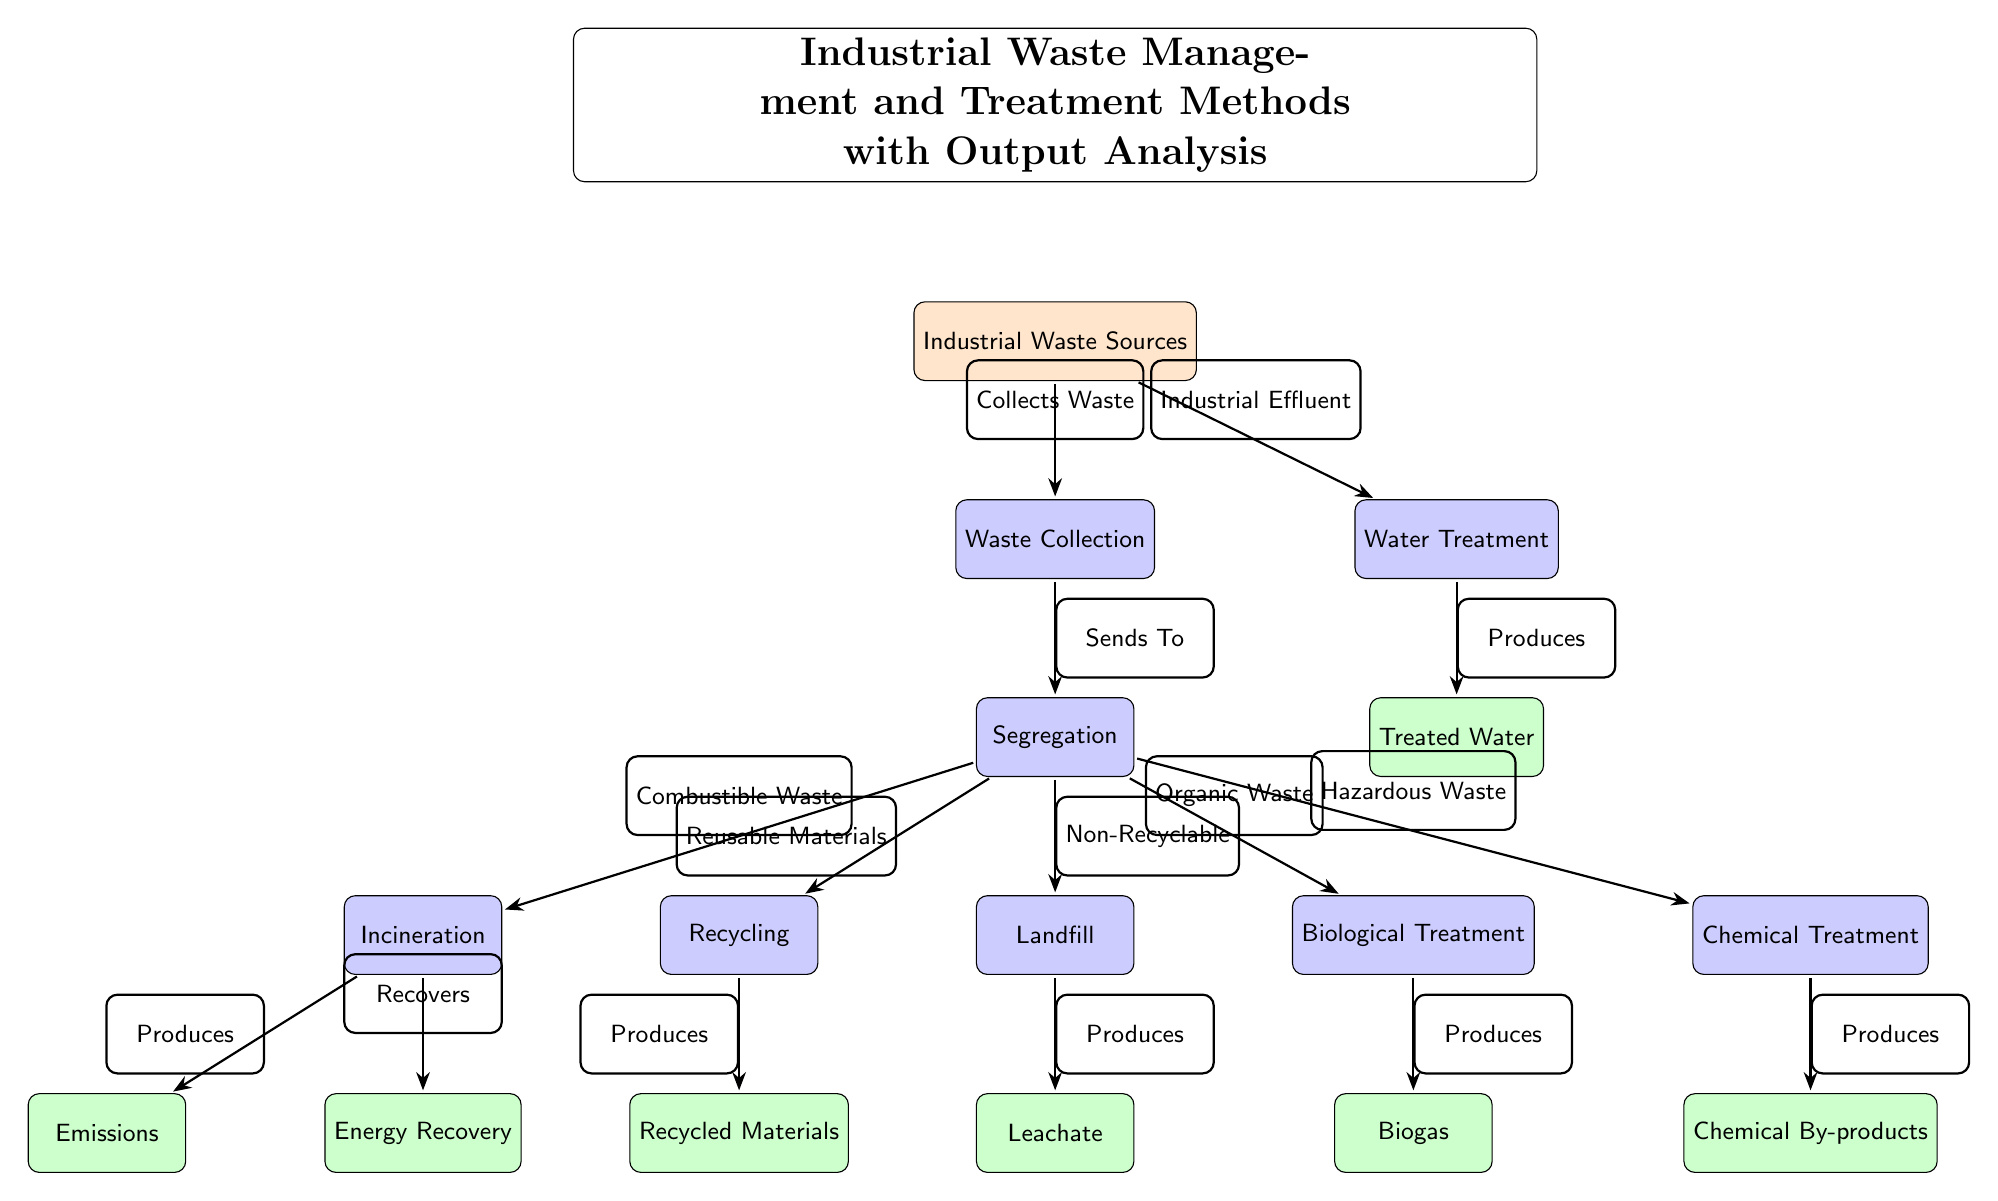What are the two main processes after waste collection? After waste collection, the diagram shows that the two main processes are segregation and water treatment. Segregation directly follows waste collection, while water treatment is another process that includes industrial effluent as input from the industrial waste sources.
Answer: Segregation and Water Treatment How many treatment methods are shown in the diagram? The diagram lists six treatment methods: recycling, incineration, landfill, biological treatment, chemical treatment, and water treatment. These methods detail how the segregated waste can be processed after the initial waste collection.
Answer: Six What type of output does incineration produce according to the diagram? According to the diagram, incineration produces emissions and energy recovery as outputs. The relationship indicates that combustible waste collected during segregation is handled by incineration to yield these outputs.
Answer: Emissions and Energy Recovery Which treatment method is associated with organic waste? The diagram specifies that biological treatment is associated with organic waste. The pathway from segregation to biological treatment illustrates that organic waste is specifically processed through this method.
Answer: Biological Treatment What is produced from chemical treatment? Chemical treatment produces chemical by-products as indicated in the diagram, showing the outcome of handling hazardous waste through this treatment method, following the segregation stage.
Answer: Chemical By-products Which output is connected to water treatment? The output directly connected to water treatment, according to the diagram, is treated water. This follows the water treatment process after the input of industrial effluent from industrial waste sources.
Answer: Treated Water Which treatment method has two distinct outputs? Incineration is the treatment method that has two distinct outputs, namely emissions and energy recovery. The dual output emphasizes the various results that can come from the incineration process in managing waste.
Answer: Incineration From where does industrial effluent directly feed into the diagram? Industrial effluent directly feeds into the water treatment process in the diagram. This highlights its flow as a significant component of waste management that requires specific treatment distinct from other waste types.
Answer: Water Treatment 